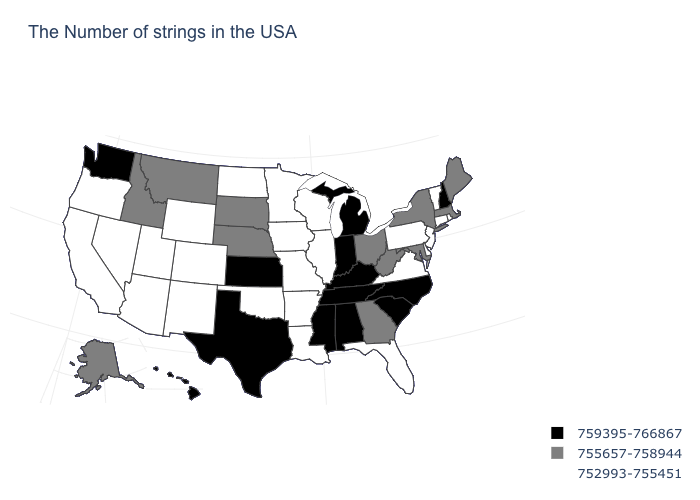Among the states that border Tennessee , which have the lowest value?
Short answer required. Virginia, Missouri, Arkansas. What is the value of New Hampshire?
Keep it brief. 759395-766867. What is the value of Oklahoma?
Answer briefly. 752993-755451. What is the lowest value in states that border Kentucky?
Write a very short answer. 752993-755451. Name the states that have a value in the range 752993-755451?
Concise answer only. Rhode Island, Vermont, Connecticut, New Jersey, Delaware, Pennsylvania, Virginia, Florida, Wisconsin, Illinois, Louisiana, Missouri, Arkansas, Minnesota, Iowa, Oklahoma, North Dakota, Wyoming, Colorado, New Mexico, Utah, Arizona, Nevada, California, Oregon. Does the first symbol in the legend represent the smallest category?
Write a very short answer. No. Among the states that border Connecticut , does Rhode Island have the lowest value?
Concise answer only. Yes. What is the highest value in the MidWest ?
Keep it brief. 759395-766867. Does the map have missing data?
Keep it brief. No. Name the states that have a value in the range 752993-755451?
Keep it brief. Rhode Island, Vermont, Connecticut, New Jersey, Delaware, Pennsylvania, Virginia, Florida, Wisconsin, Illinois, Louisiana, Missouri, Arkansas, Minnesota, Iowa, Oklahoma, North Dakota, Wyoming, Colorado, New Mexico, Utah, Arizona, Nevada, California, Oregon. Does Iowa have the same value as Pennsylvania?
Concise answer only. Yes. Does the first symbol in the legend represent the smallest category?
Write a very short answer. No. What is the value of Michigan?
Write a very short answer. 759395-766867. What is the value of Louisiana?
Write a very short answer. 752993-755451. Does South Carolina have the highest value in the South?
Short answer required. Yes. 